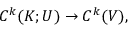<formula> <loc_0><loc_0><loc_500><loc_500>C ^ { k } ( K ; U ) \to C ^ { k } ( V ) ,</formula> 